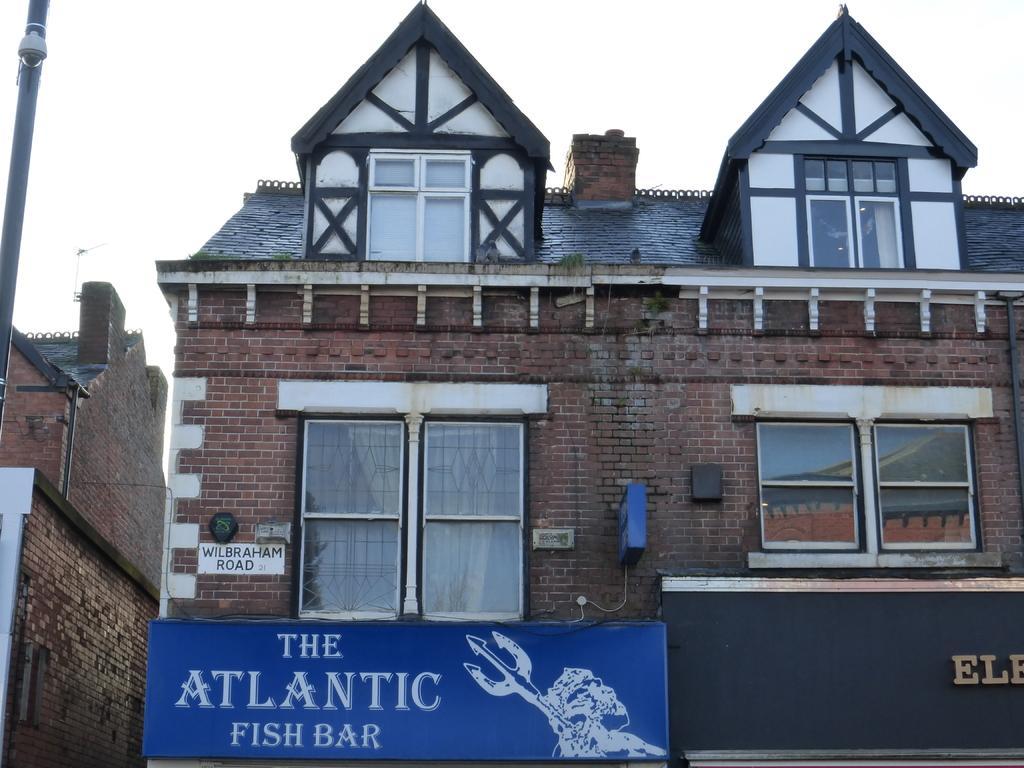In one or two sentences, can you explain what this image depicts? In the center of the image there is a building. To the left side of the image there is a pole. 